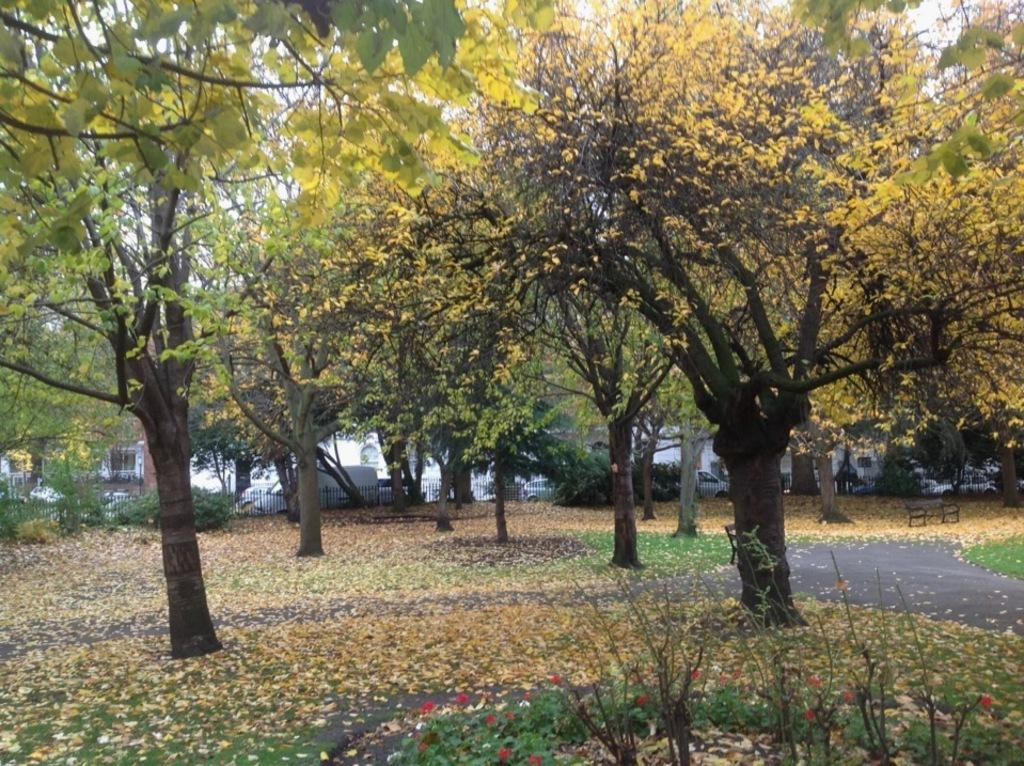What type of vegetation is present in the image? There are many trees in the image. What is on the ground beneath the trees? There are leaves on the ground. Where is the bench located in the image? The bench is on the right side of the image. What can be seen in the background of the image? There are vehicles visible in the background. What type of barrier is present in the image? There is a fencing in the image. What type of bird is sitting on the power lines in the image? There are no power lines or birds present in the image. 